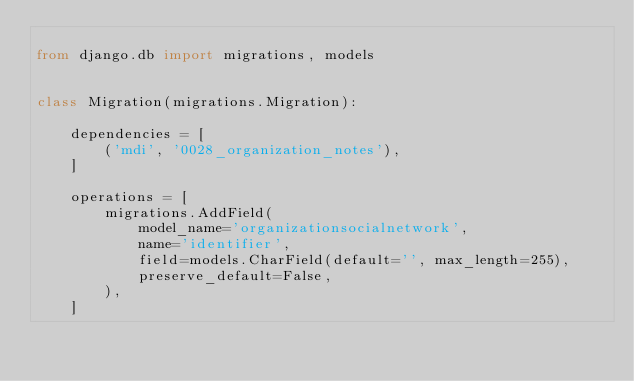Convert code to text. <code><loc_0><loc_0><loc_500><loc_500><_Python_>
from django.db import migrations, models


class Migration(migrations.Migration):

    dependencies = [
        ('mdi', '0028_organization_notes'),
    ]

    operations = [
        migrations.AddField(
            model_name='organizationsocialnetwork',
            name='identifier',
            field=models.CharField(default='', max_length=255),
            preserve_default=False,
        ),
    ]
</code> 